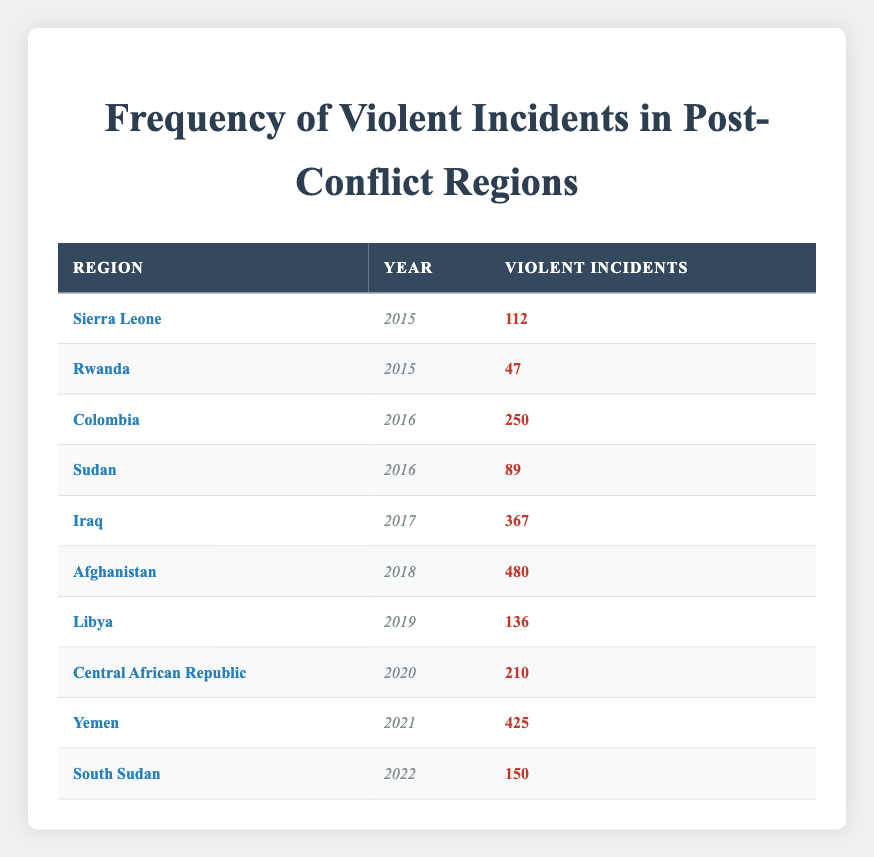What is the highest number of violent incidents reported in a single year in the table? The table shows various post-conflict regions and the corresponding violent incidents for each year. By scanning through the data, we find that Afghanistan in 2018 has the highest number of violent incidents reported, which is 480.
Answer: 480 Which region reported the least violent incidents in the year 2015? In 2015, the table indicates that Rwanda reported the least violent incidents with a total of 47, while Sierra Leone reported 112 in the same year.
Answer: 47 How many violent incidents were reported in total for the years 2016 and 2017? To find the total incidents for 2016 and 2017, I need to sum the incidents from Colombia (250), Sudan (89) for 2016, and Iraq (367) for 2017. The total is 250 + 89 + 367 = 706.
Answer: 706 Did Yemen report more violent incidents than Iraq in their respective years? The table shows Yemen reported 425 incidents in 2021, while Iraq reported 367 incidents in 2017. Since 425 is greater than 367, the answer is yes.
Answer: Yes What was the average number of violent incidents reported in the years 2019 and 2020? In 2019, Libya reported 136 incidents and in 2020, the Central African Republic reported 210. To find the average, I sum the incidents (136 + 210 = 346) and then divide by the number of years (2). So, 346 / 2 = 173.
Answer: 173 How many more violent incidents were reported in Afghanistan in 2018 compared to Yemen in 2021? Afghanistan reported 480 incidents in 2018 and Yemen reported 425 incidents in 2021. The difference is calculated by subtracting Yemen's incidents from Afghanistan's: 480 - 425 = 55.
Answer: 55 Which region experienced a reduction in violent incidents from 2015 to 2016? Looking at the data, Sierra Leone had 112 incidents in 2015 and Colombia reported 250 in 2016. Since there is no case where the number in 2016 is less than the one in 2015 when comparing these regions, the region that experienced a reduction doesn't exist in the given data.
Answer: No Is it true that the Central African Republic reported more violent incidents in 2020 than Libya in 2019? Central African Republic reported 210 incidents in 2020, while Libya reported 136 incidents in 2019. Since 210 is greater than 136, the statement is true.
Answer: Yes 